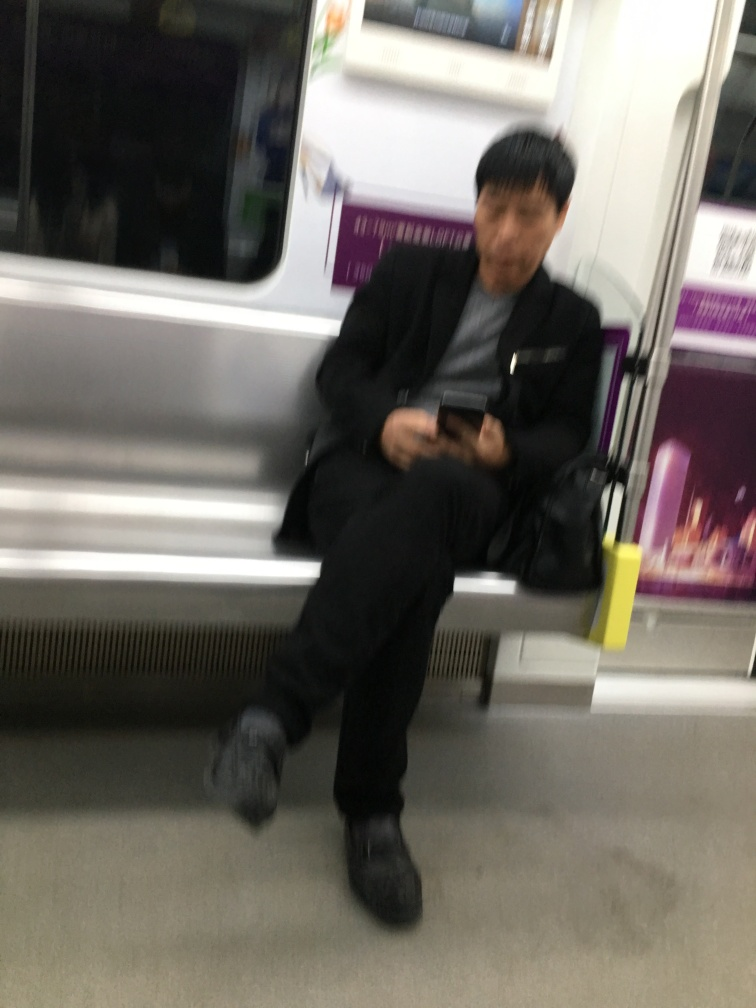Is there anything about this image that suggests a specific time of day? The image's low lighting and the fact that the passenger is wearing a coat suggest it could be early morning or late evening, typically colder and darker parts of the day. 